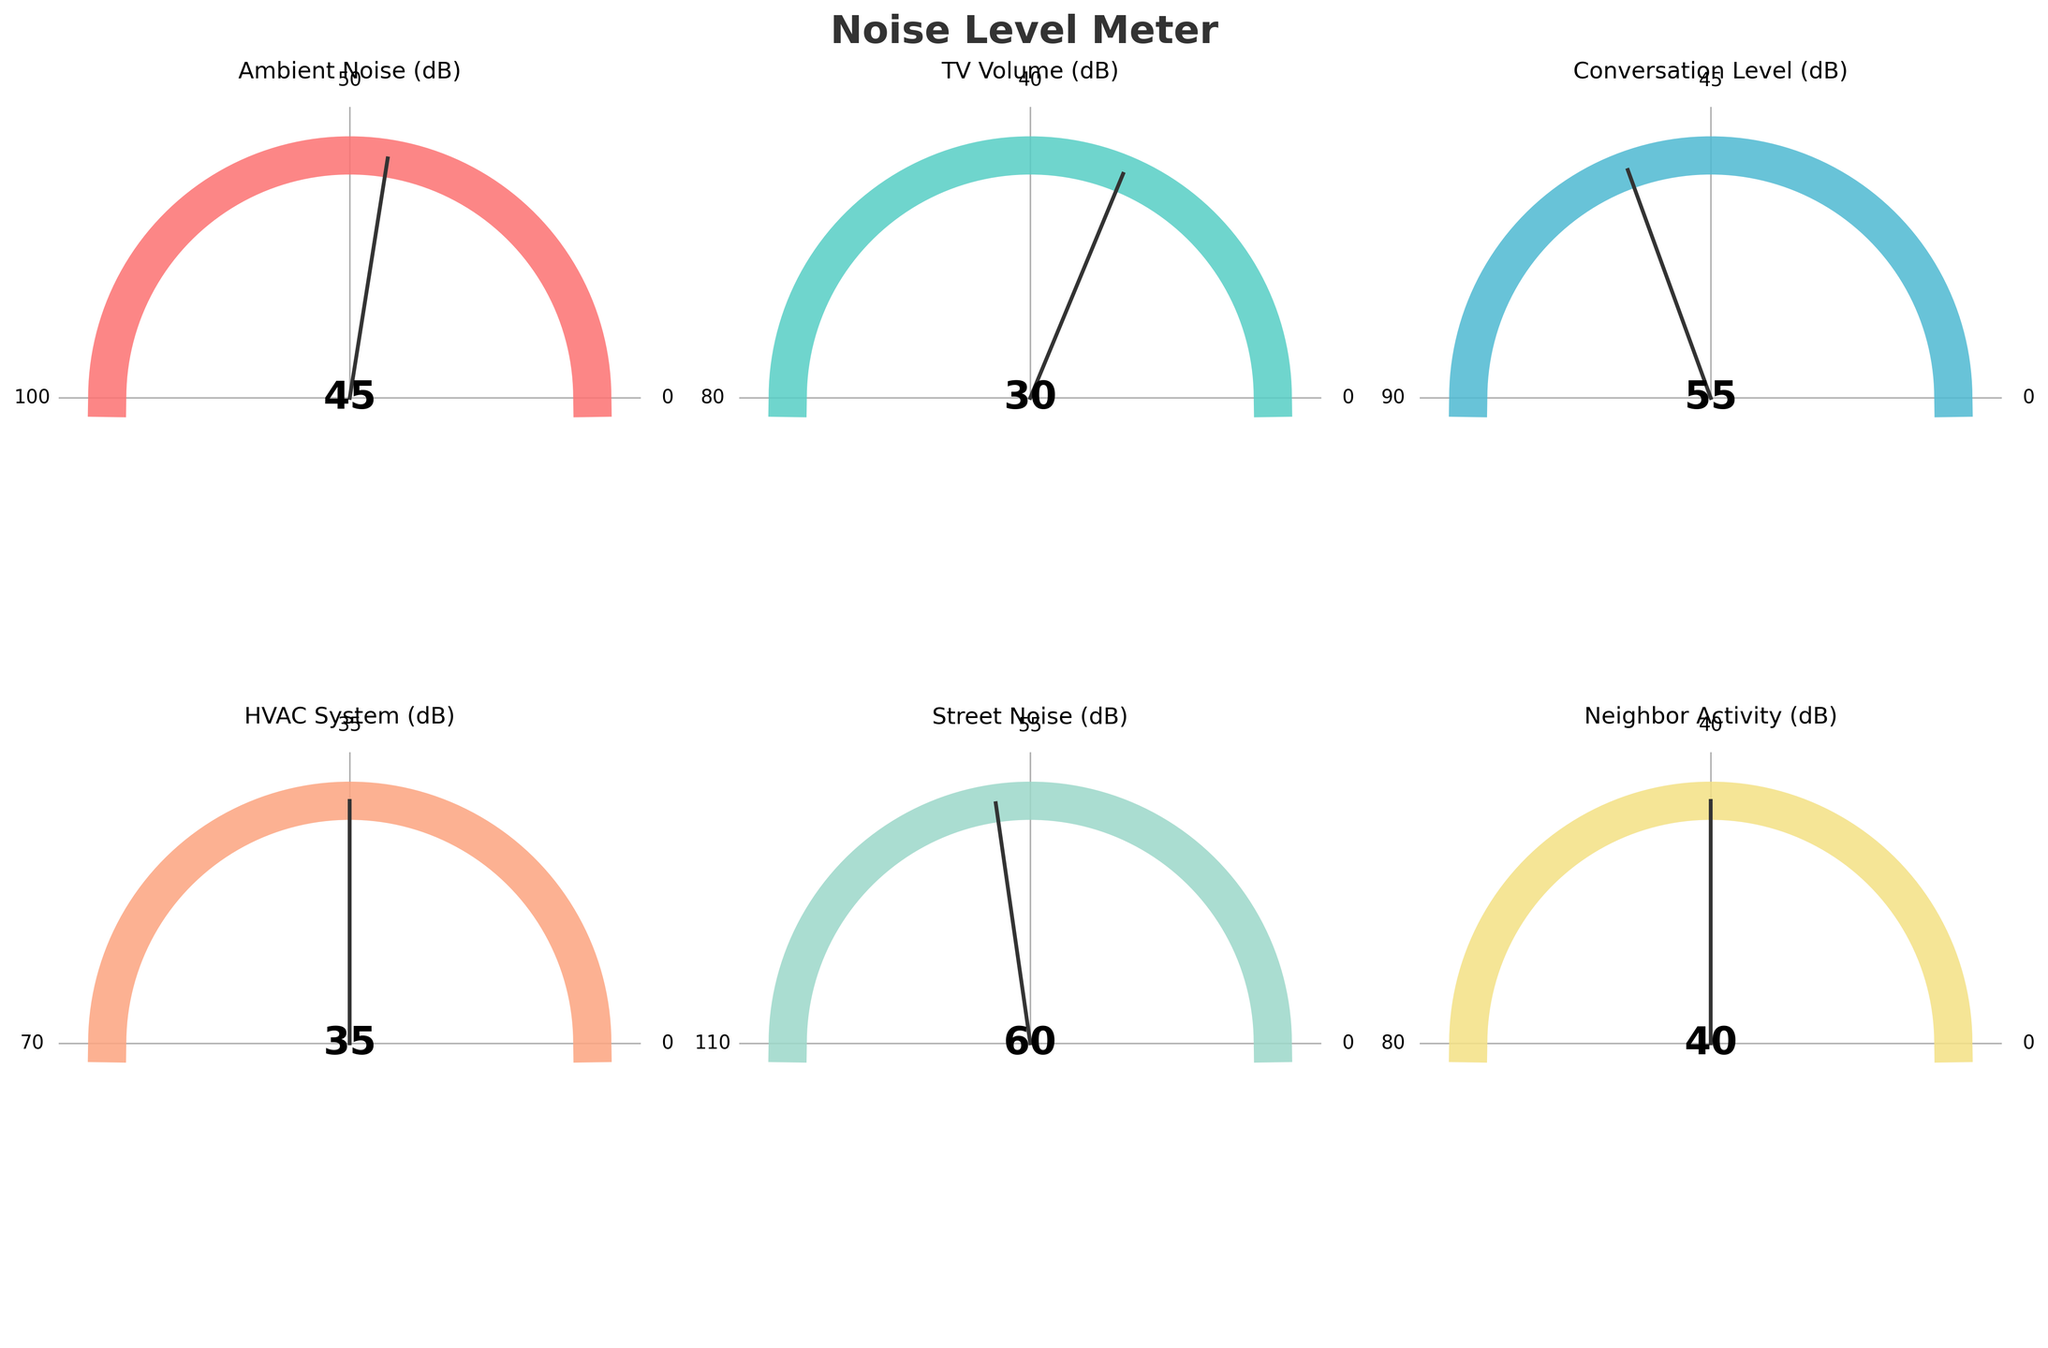What's the title of the figure? The title of the figure is generally found at the top of a chart and serves as a summary of what the chart represents. In this case, the title is "Noise Level Meter."
Answer: Noise Level Meter How many categories of noise levels are displayed? To determine the number of categories, simply count each individual category labeled on the gauge charts. There are six gauge charts, each representing a different category.
Answer: 6 Which category has the highest noise level? To determine the category with the highest noise level, compare the values represented in each gauge chart. The gauge for "Street Noise" shows a value of 60 dB, which is the highest among all categories.
Answer: Street Noise What is the value for TV Volume? Locate the gauge chart labeled "TV Volume" and read the numerical value displayed in the center of the gauge. The TV Volume reads 30 dB.
Answer: 30 dB Which noise level is closest to 50 dB? Look at the values in each gauge chart and find the one that is nearest to 50 dB. "Conversation Level" displays a noise level of 55 dB, which is closest to 50 dB.
Answer: Conversation Level What is the average noise level of Ambient Noise and Neighbor Activity? Add the values of "Ambient Noise" (45 dB) and "Neighbor Activity" (40 dB), then divide by 2 to find the average: (45 + 40) / 2 = 42.5 dB.
Answer: 42.5 dB Which categories have noise levels over 50 dB? Check each gauge chart to see if the displayed value is above 50 dB. "Conversation Level" at 55 dB and "Street Noise" at 60 dB are both over 50 dB.
Answer: Conversation Level, Street Noise How much higher is the street noise compared to TV volume? Subtract the TV Volume (30 dB) from the Street Noise (60 dB) to find the difference: 60 dB - 30 dB = 30 dB.
Answer: 30 dB What is the range of values that Ambient Noise can take? The range for each category can be seen from the minimum and maximum tick labels on the gauge charts. For Ambient Noise, the range is from 0 to 100 dB.
Answer: 0 to 100 dB Which category has the smallest possible maximum value? Compare the maximum values shown on each gauge chart. The "HVAC System" has the smallest maximum value of 70 dB.
Answer: HVAC System 